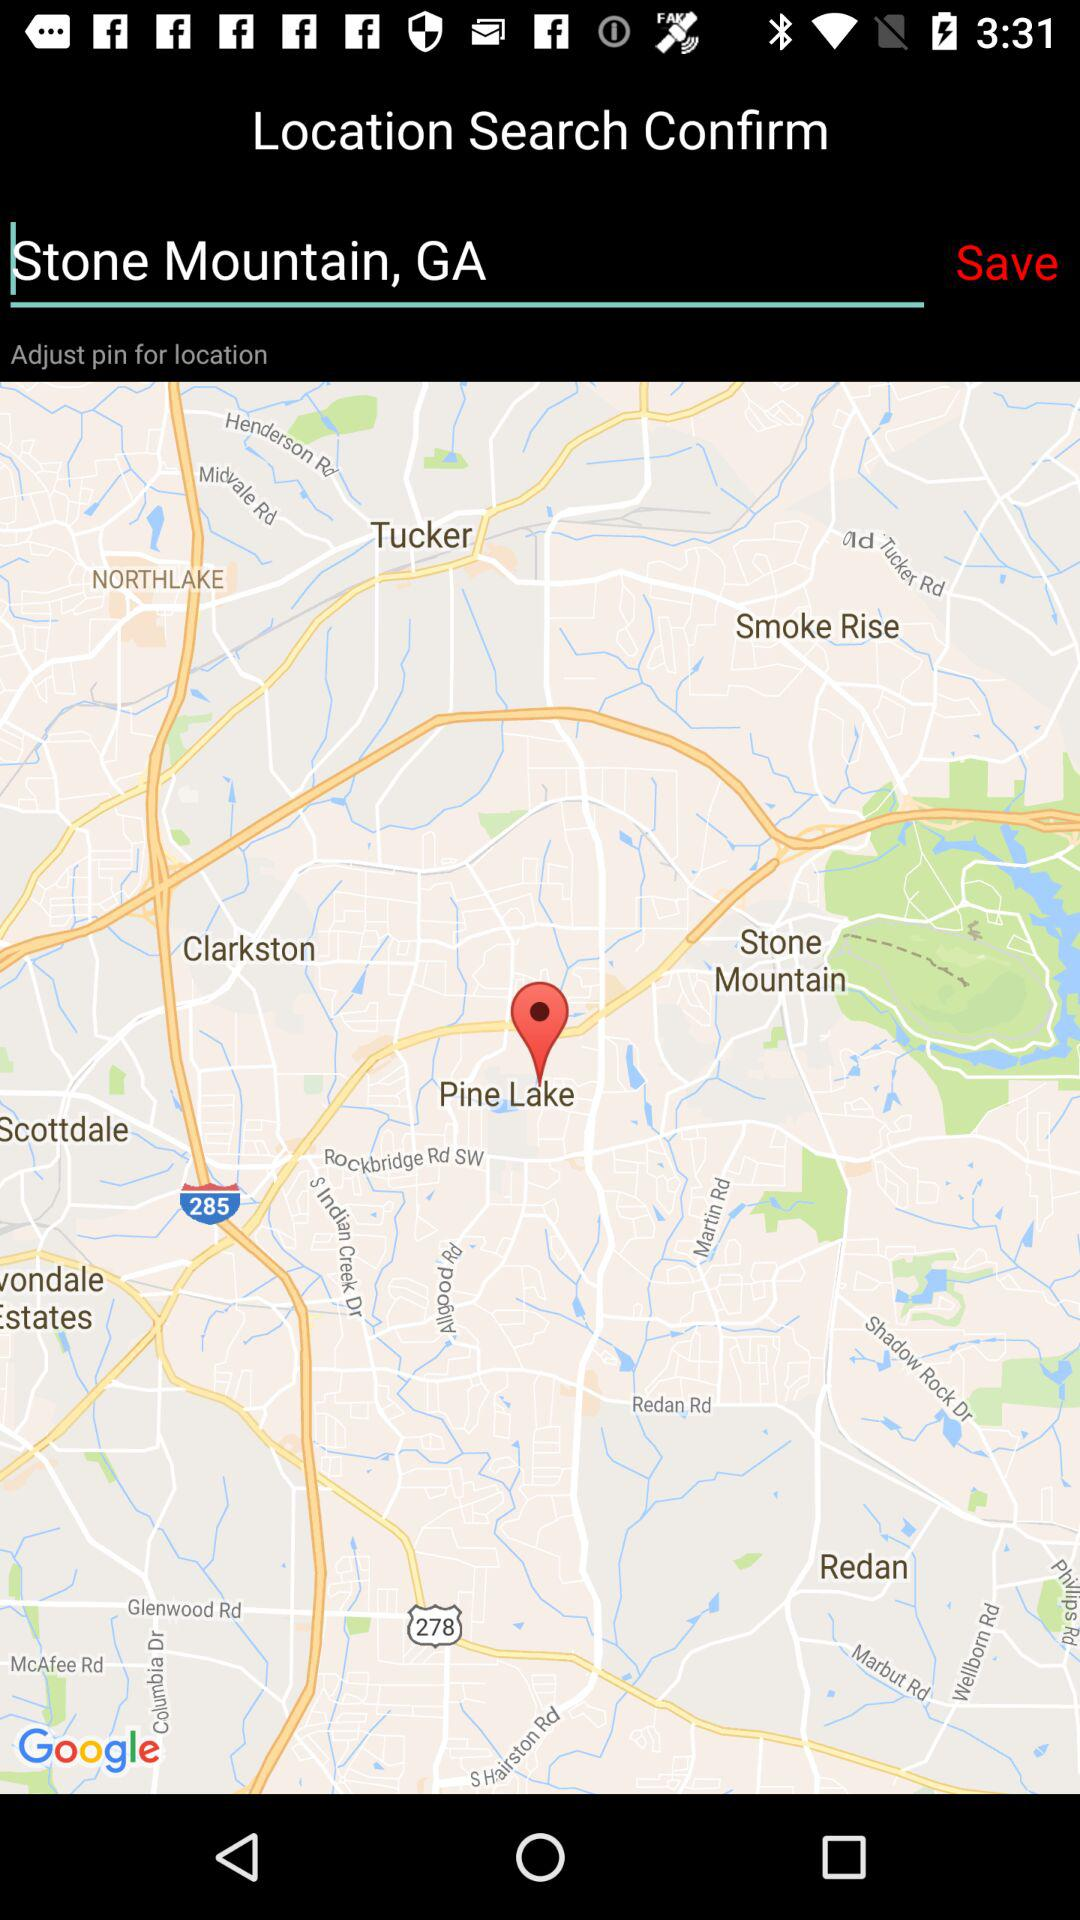How many miles away is Stone Mountain, Georgia?
When the provided information is insufficient, respond with <no answer>. <no answer> 